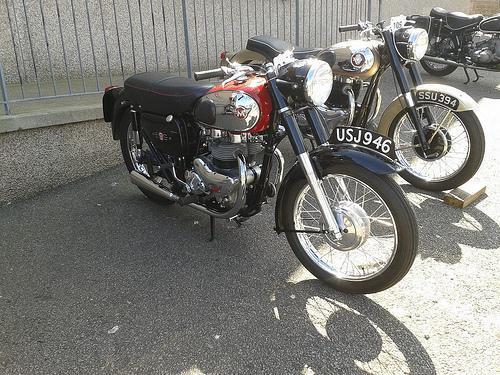How many motorcycles are there?
Give a very brief answer. 3. 